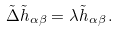Convert formula to latex. <formula><loc_0><loc_0><loc_500><loc_500>\tilde { \Delta } \tilde { h } _ { \alpha \beta } = \lambda \tilde { h } _ { \alpha \beta } \, .</formula> 